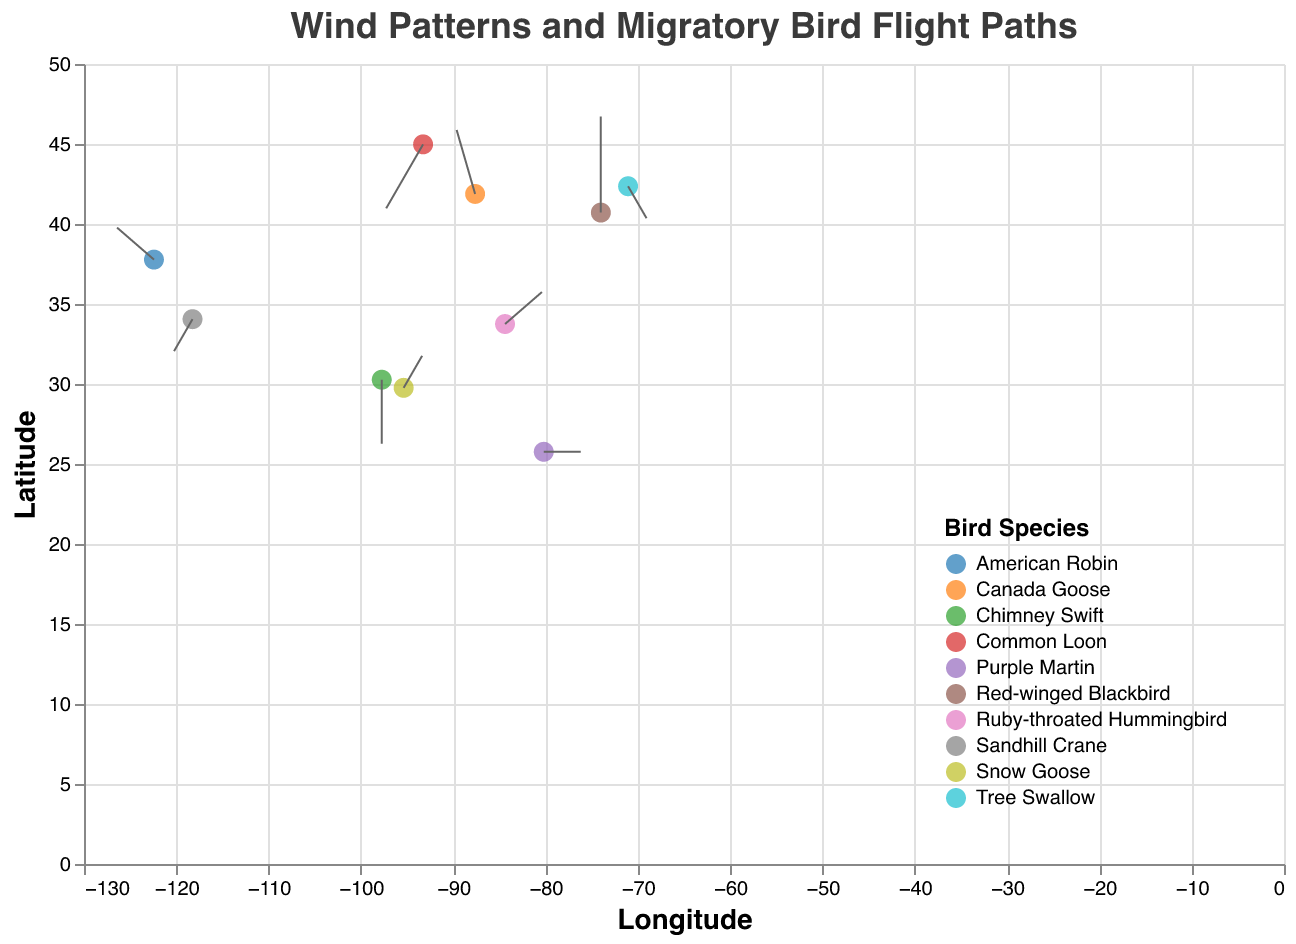What is the title of the plot? The title of the plot is displayed at the top of the figure, typically in a font size that stands out. In this case, it is "Wind Patterns and Migratory Bird Flight Paths", which describes the main focus of the plot.
Answer: Wind Patterns and Migratory Bird Flight Paths Which bird species is represented at longitude -122.4194 and latitude 37.7749? On the plot, look for the data point located at longitude -122.4194 and latitude 37.7749. The tooltip or color legend will indicate this point represents the American Robin.
Answer: American Robin How many bird species are represented in the plot? Check the legend on the plot, where each bird species is assigned a unique color. Count the number of distinct colors or legend entries. There are ten bird species in the plot.
Answer: Ten Which bird species experiences the strongest northeastern wind direction? Northeastern wind direction is indicated by positive values for both wind_direction_x and wind_direction_y. Identify the data points with both positive x and y wind directions. Ruby-throated Hummingbird, located at longitude -84.3880 and latitude 33.7490, experiences the strongest northeastern wind as its wind values are (2, 1).
Answer: Ruby-throated Hummingbird What are the wind directions for the Common Loon at its location? Locate the Common Loon on the plot using the legend or tooltip. The bird's data point is at longitude -93.2650 and latitude 44.9778. The wind directions for this location are -2 in the x direction and -2 in the y direction.
Answer: -2, -2 Which bird species flies towards the south due to wind patterns? A southern wind direction is indicated by a negative y value for wind_direction_y. Identify data points with negative wind_direction_y values, such as at (0, -2), corresponding to the Chimney Swift.
Answer: Chimney Swift Compare the wind direction of the Canada Goose and the American Robin. Which bird species has a stronger wind assistance? The strength of the wind assistance can be observed by the length of the wind vector (magnitude). Calculate the magnitude for both vectors: Canada Goose (-1, 2) has a magnitude of sqrt(1^2 + 2^2) ≈ 2.24; American Robin (-2, 1) has a magnitude of sqrt(2^2 + 1^2) ≈ 2.24. Both have similar wind assistance.
Answer: Both have equal wind assistance What latitude figure is the Sandhill Crane located at? Look for the Sandhill Crane data point in the plot using the legend or tooltip. The Sandhill Crane is located at longitude -118.2437 and latitude 34.0522.
Answer: 34.0522 How does the wind pattern affect the flight path of the Red-winged Blackbird? Identify the wind direction for the Red-winged Blackbird at longitude -74.0060 and latitude 40.7128. The wind direction is (0, 3), indicating that the wind is pushing the bird directly northward (north).
Answer: Northward What is the median latitude value amongst all bird species locations? List all bird latitude values: 37.7749, 41.8781, 40.7128, 29.7604, 25.7617, 34.0522, 44.9778, 42.3601, 30.2672, 33.7490. Arrange and find the middle value in even-length data: (25.7617, 29.7604, 30.2672, 33.7490, 34.0522, 37.7749, 40.7128, 41.8781, 42.3601, 44.9778), median between 34.0522 and 37.7749 = (34.0522 + 37.7749)/2 = 35.91355.
Answer: 35.91355 